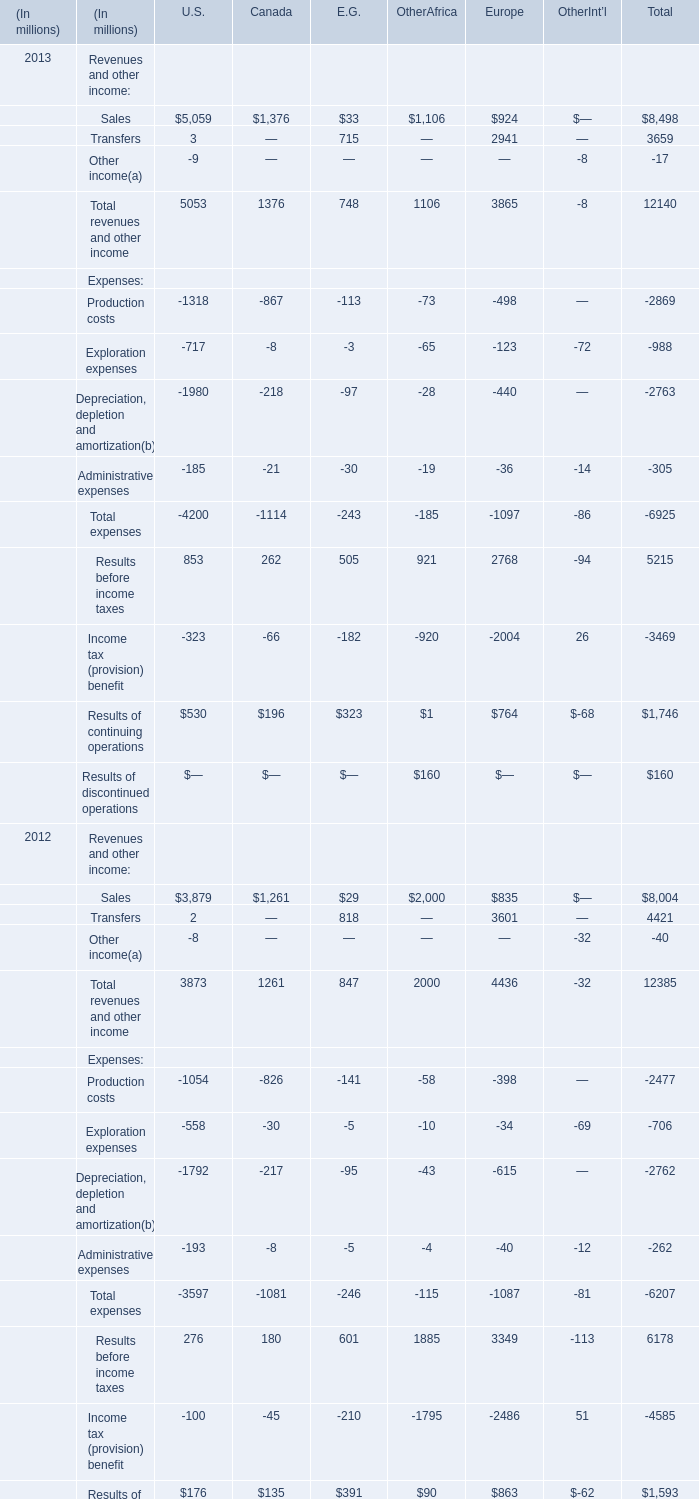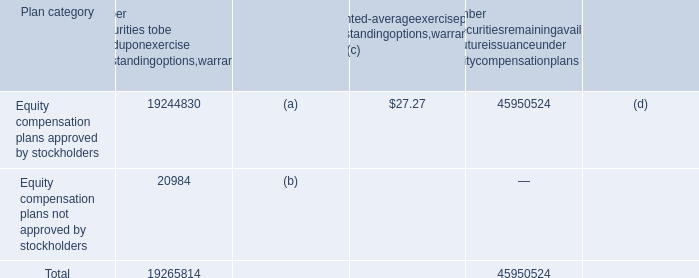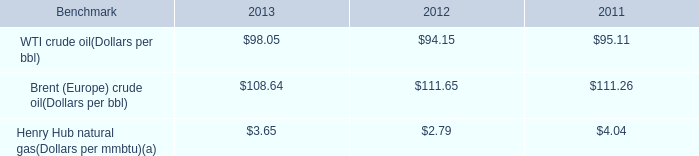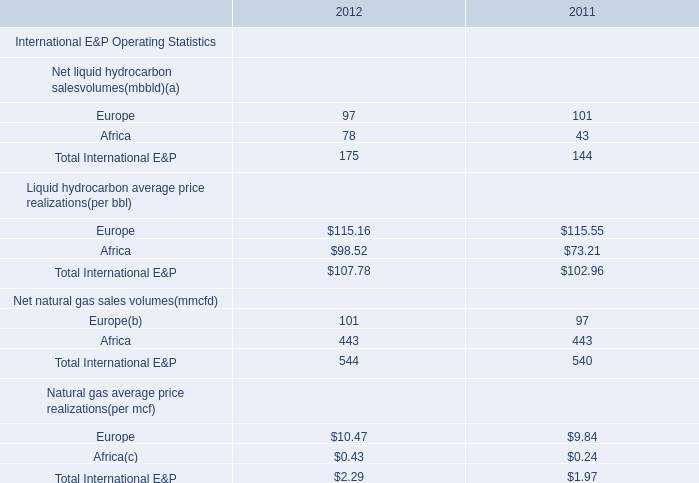In the section with the most Sales, what is the growth rate of Total revenues and other income? (in %) 
Computations: ((5053 - 3873) / 3873)
Answer: 0.30467. 